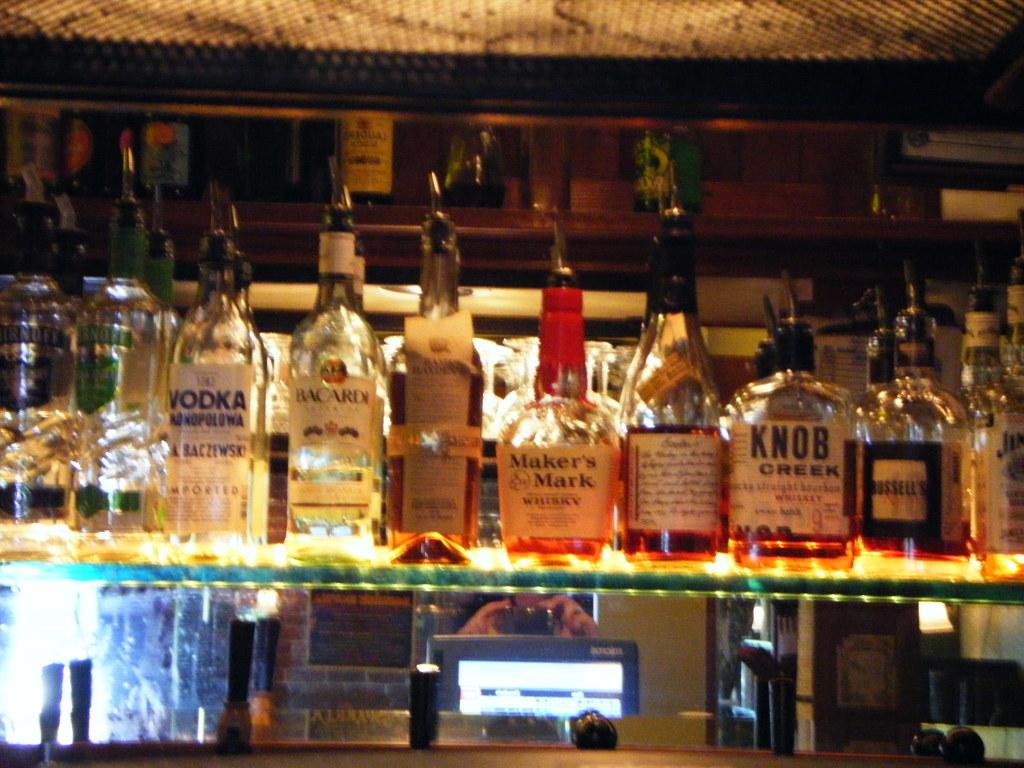What is the name of the whiskey with the red wax neck?
Provide a short and direct response. Maker's mark. What brand of alcohol is in the middle?
Give a very brief answer. Maker's mark. 